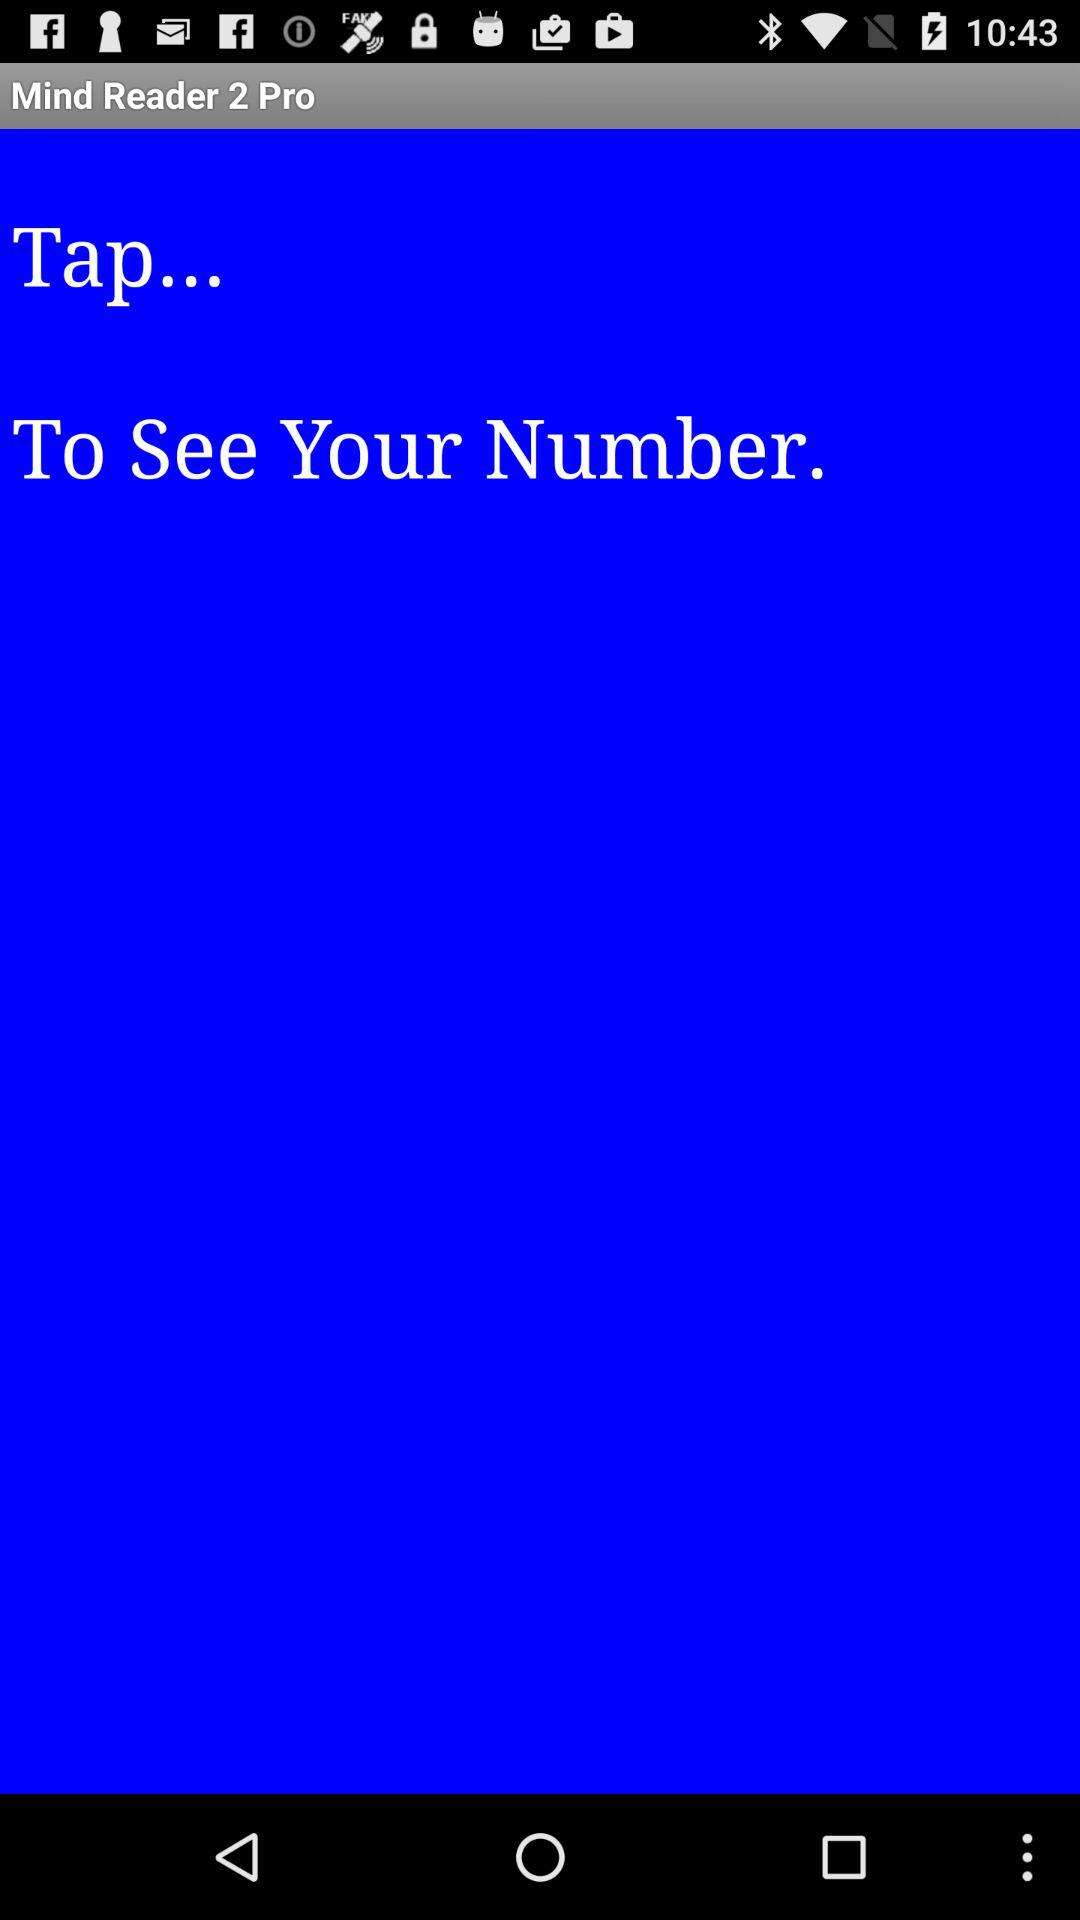What is the application name? The application name is "Mind Reader 2 Pro". 